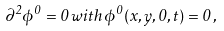<formula> <loc_0><loc_0><loc_500><loc_500>\partial ^ { 2 } \phi ^ { 0 } = 0 \, w i t h \, \phi ^ { 0 } ( x , y , 0 , t ) = 0 \, ,</formula> 